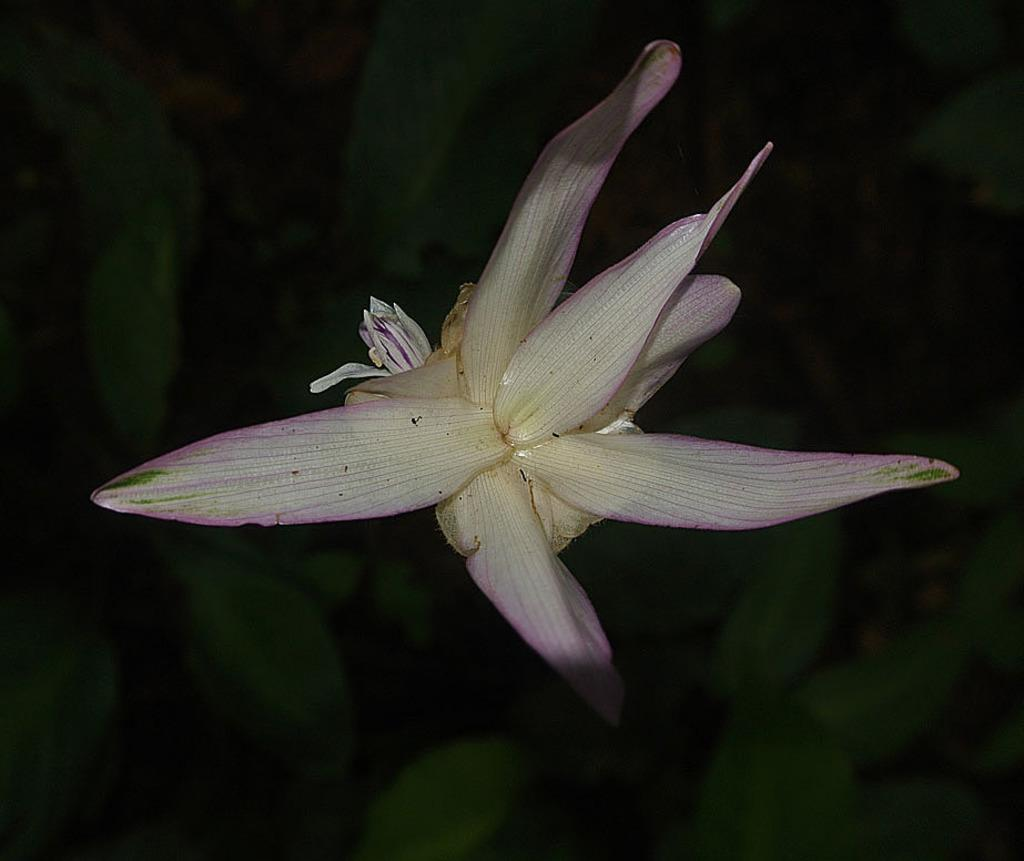What is the main subject of the image? There is a flower in the image. Can you describe the background of the image? There is a group of plants in the background of the image. What nation is the flower representing in the image? The image does not depict a flower representing a nation; it simply shows a flower. 